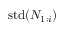Convert formula to latex. <formula><loc_0><loc_0><loc_500><loc_500>s t d ( N _ { 1 \colon i } )</formula> 